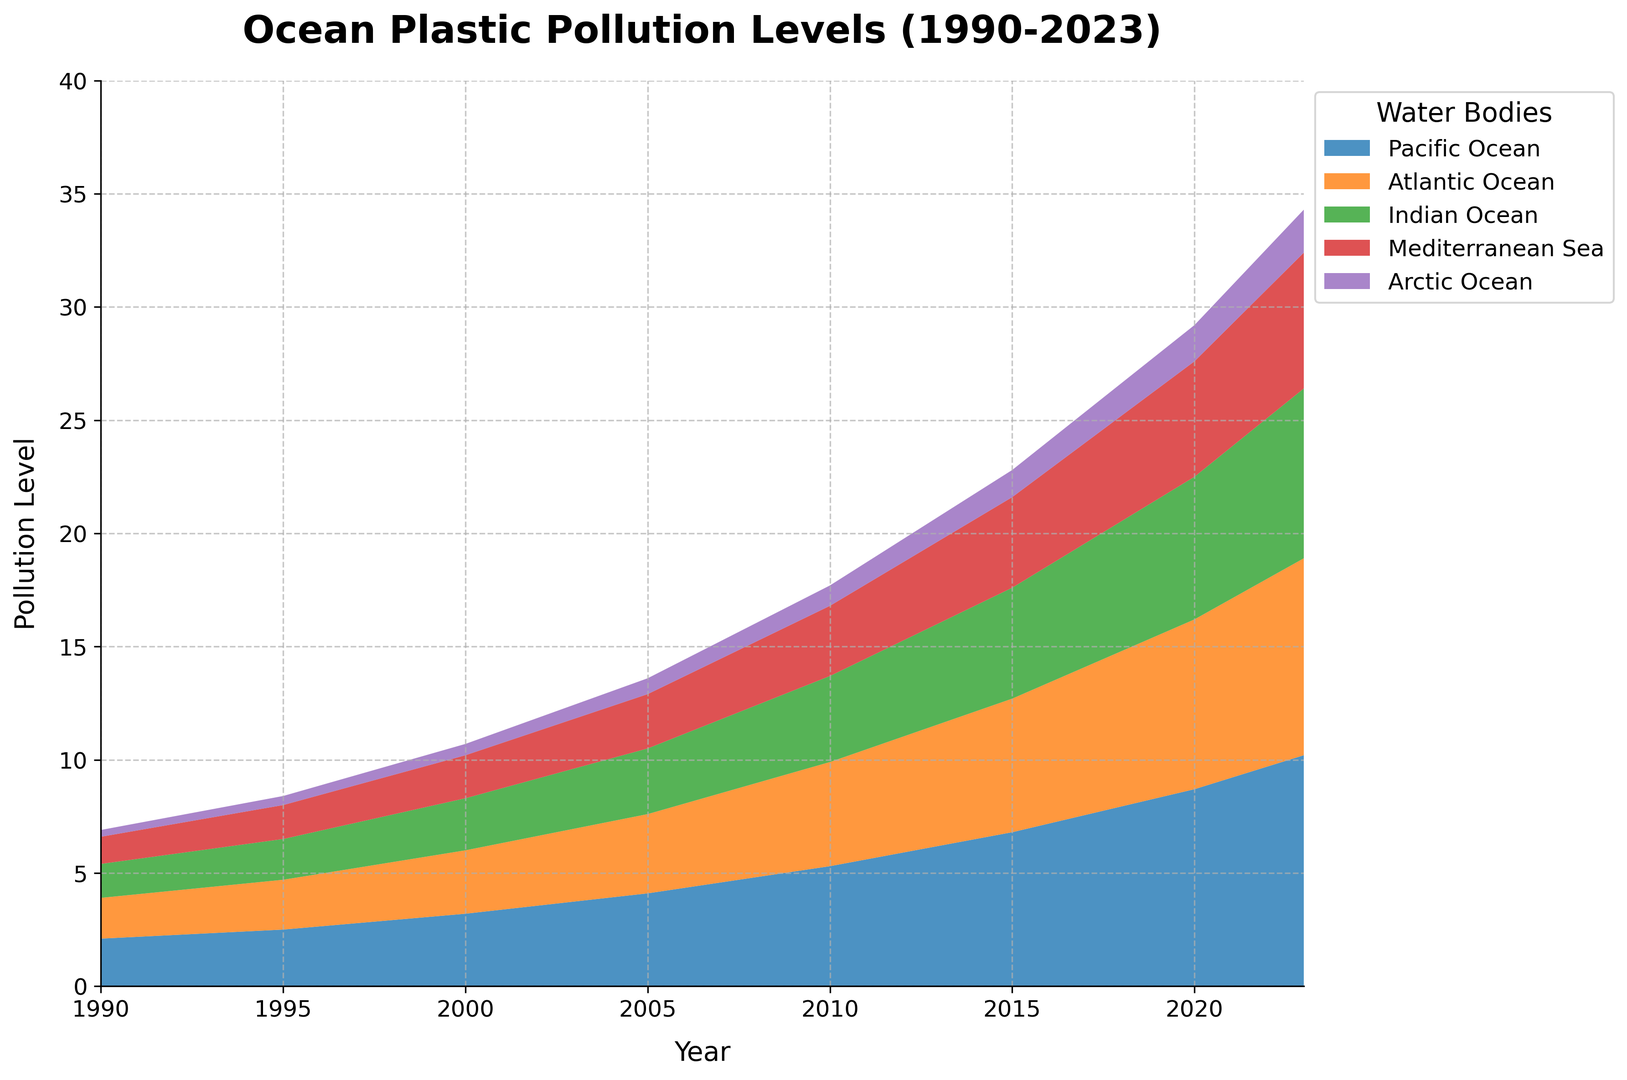What is the trend of plastic pollution levels in the Pacific Ocean from 1990 to 2023? To understand the trend, observe the height of the colored area representing the Pacific Ocean. From 1990 to 2023, the height consistently increases, showing a rising trend in pollution levels.
Answer: Rising Which ocean had the second highest level of plastic pollution in 2015? Look at the 2015 mark on the x-axis and compare the heights of the stacked areas. The Atlantic Ocean's height is above the Indian Ocean but below the Pacific Ocean, making it the second highest.
Answer: Atlantic Ocean By how much did the plastic pollution level in the Arctic Ocean increase from 1990 to 2023? Identify the pollution levels in 1990 (0.3) and 2023 (1.9) for the Arctic Ocean from the figure and calculate the difference (1.9 - 0.3).
Answer: 1.6 units Which water body shows the steepest increase in plastic pollution levels after 2010? Observe the slope of each colored area post-2010. The Pacific Ocean's slope appears the steepest, indicating the most rapid increase.
Answer: Pacific Ocean What is the combined plastic pollution level of the Atlantic and Indian Oceans in 2000? Sum the pollution levels of the Atlantic Ocean (2.8) and the Indian Ocean (2.3) for the year 2000 (2.8 + 2.3).
Answer: 5.1 units How has the pollution level in the Mediterranean Sea changed from 1990 to 2023 in comparison to the Arctic Ocean? Examine the visual height changes from 1990 to 2023 for both. The Mediterranean Sea increased from 1.2 to 6.0, a difference of 4.8, while the Arctic Ocean increased from 0.3 to 1.9, a difference of 1.6. The Mediterranean Sea saw a larger increase.
Answer: Mediterranean Sea increased more What is the average change in plastic pollution levels per year for the Pacific Ocean from 1990 to 2023? Calculate the total increase from 1990 to 2023 (10.2 - 2.1 = 8.1) and divide by the number of years (2023 - 1990 = 33). 8.1 / 33 ≈ 0.245
Answer: ≈ 0.245 units per year Between which consecutive years did the Atlantic Ocean see the largest increase in plastic pollution levels? Evaluate year-to-year increases for the Atlantic Ocean and find the largest difference: 2020 to 2021 (7.5 to 7.9) and 2021 to 2022 (7.9 to 8.3) all show notable increases, but 2010 to 2015 (4.6 to 5.9) has the largest increase of 1.3 units.
Answer: 2010 to 2015 